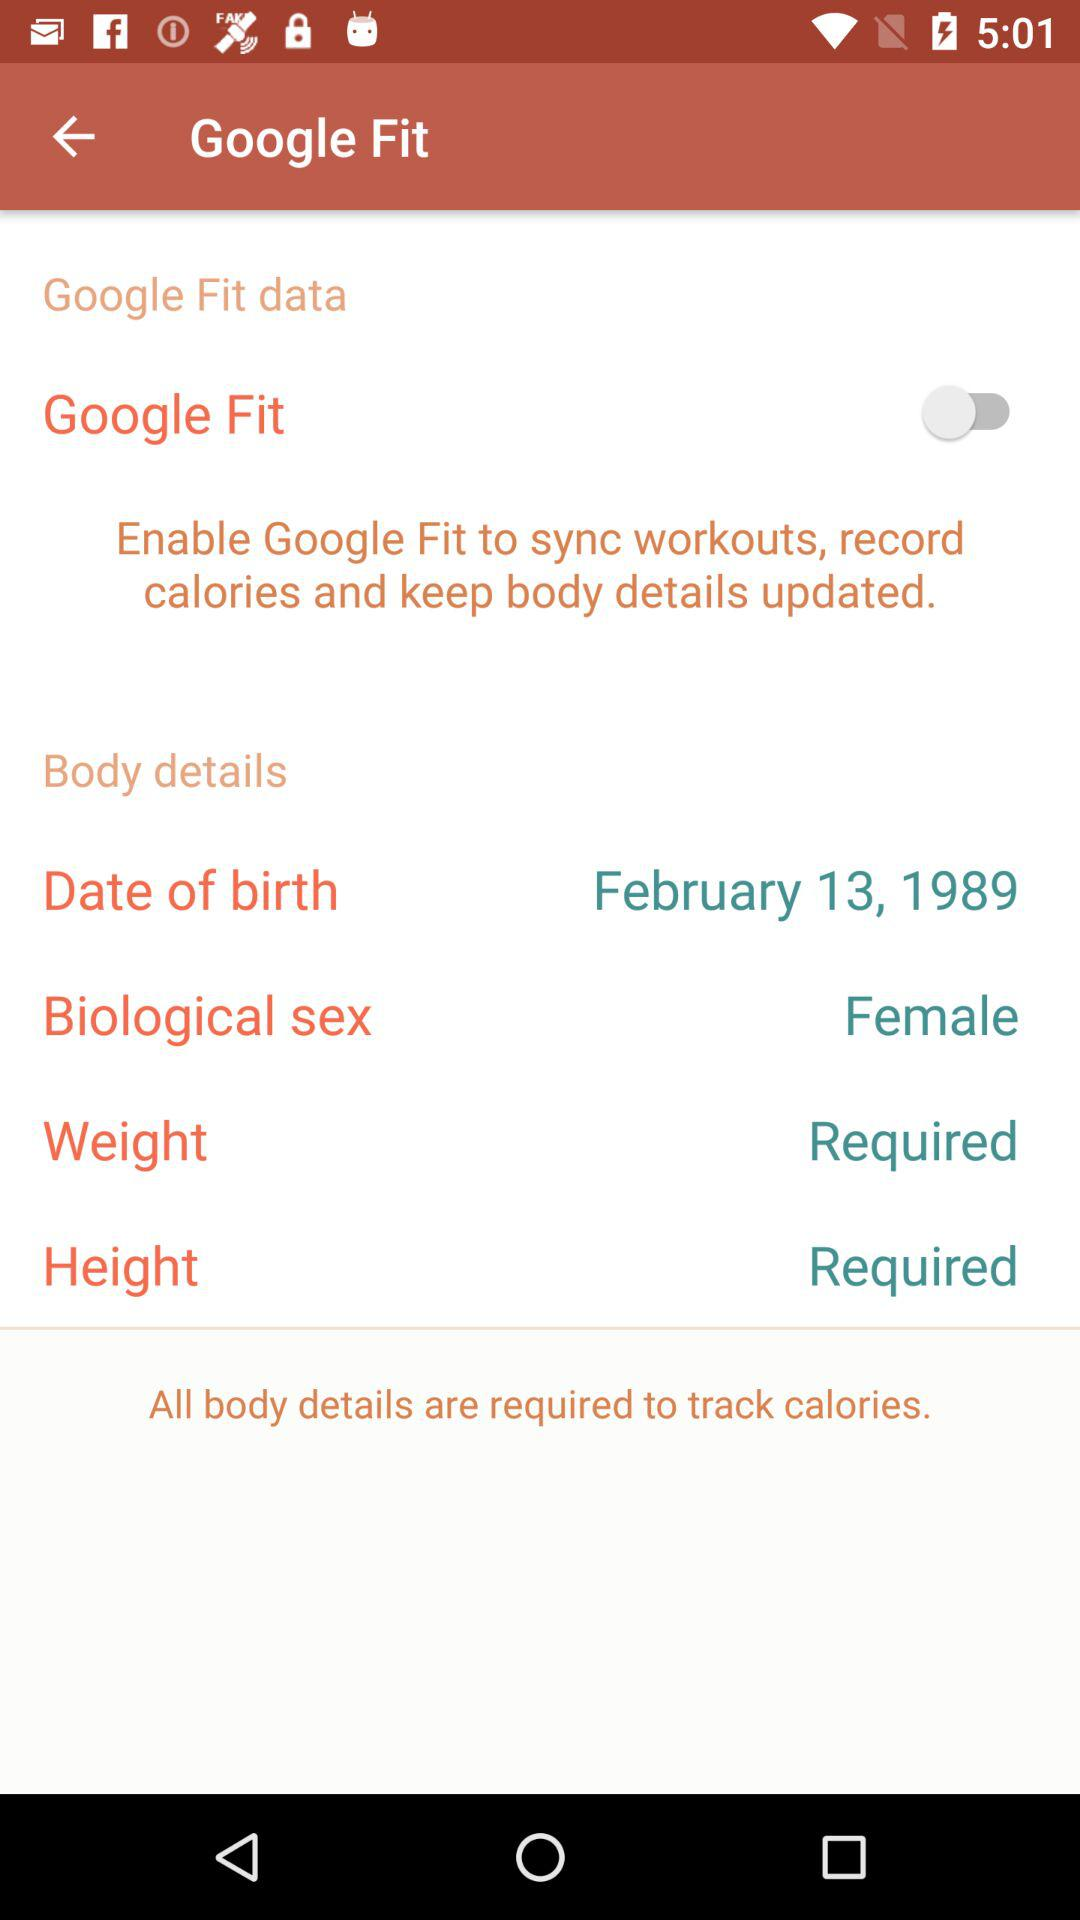What is the application name? The application name is "Google Fit". 